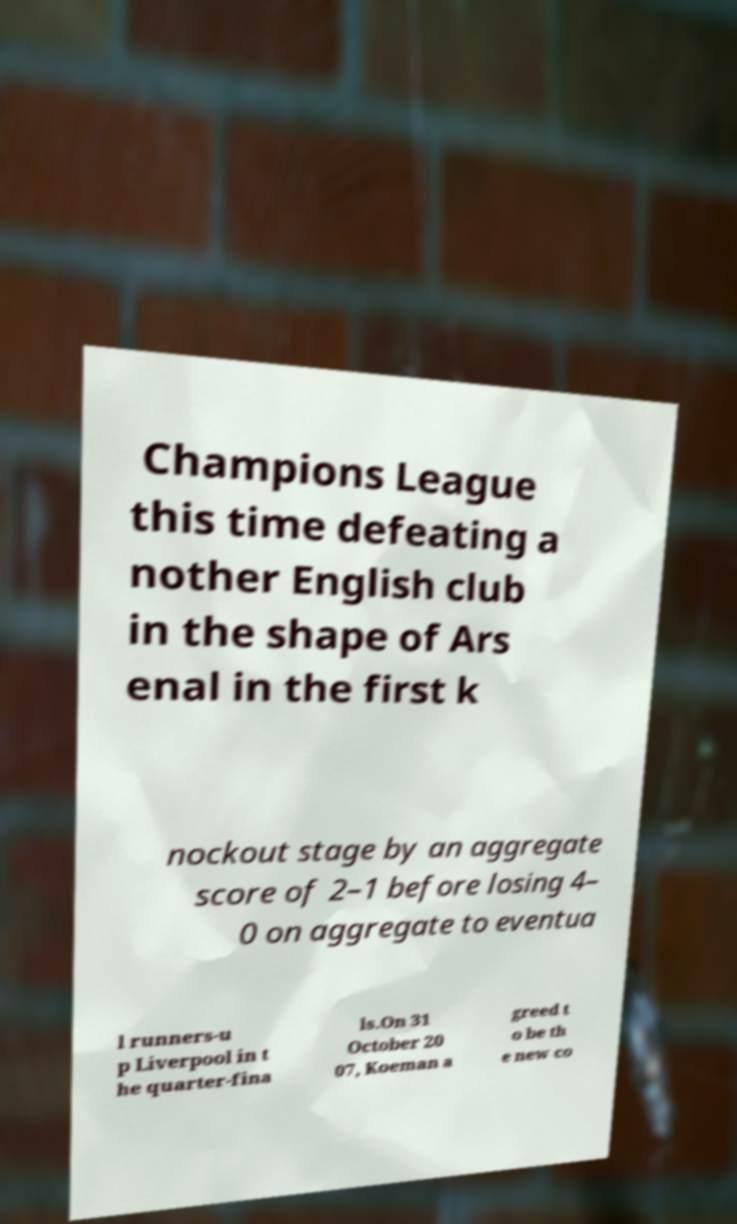What messages or text are displayed in this image? I need them in a readable, typed format. Champions League this time defeating a nother English club in the shape of Ars enal in the first k nockout stage by an aggregate score of 2–1 before losing 4– 0 on aggregate to eventua l runners-u p Liverpool in t he quarter-fina ls.On 31 October 20 07, Koeman a greed t o be th e new co 